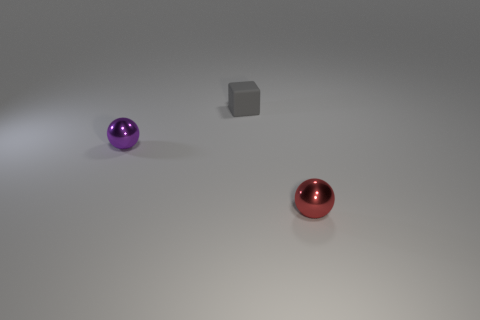Add 1 tiny purple spheres. How many objects exist? 4 Subtract all purple balls. How many balls are left? 1 Subtract all blocks. How many objects are left? 2 Subtract all yellow balls. Subtract all brown cylinders. How many balls are left? 2 Subtract all green cylinders. How many purple balls are left? 1 Subtract all big blue objects. Subtract all shiny things. How many objects are left? 1 Add 1 small purple metal spheres. How many small purple metal spheres are left? 2 Add 1 tiny red things. How many tiny red things exist? 2 Subtract 0 blue cubes. How many objects are left? 3 